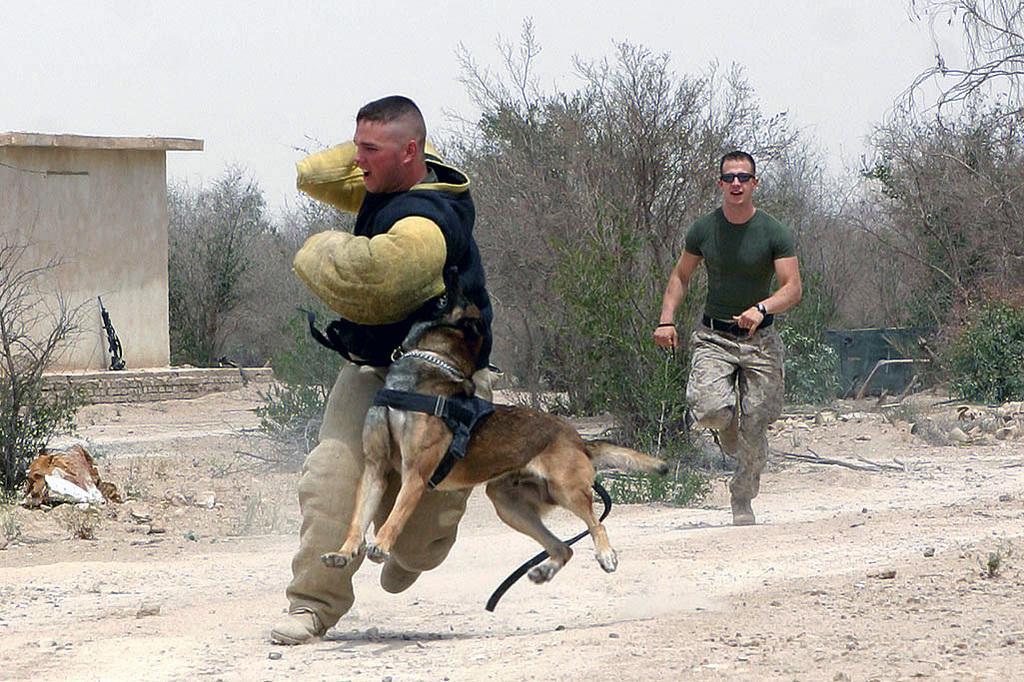Could you give a brief overview of what you see in this image? In this Image I see 2 men who are running and I see a dog over here. In the background I see the trees, a small house and the soil. 